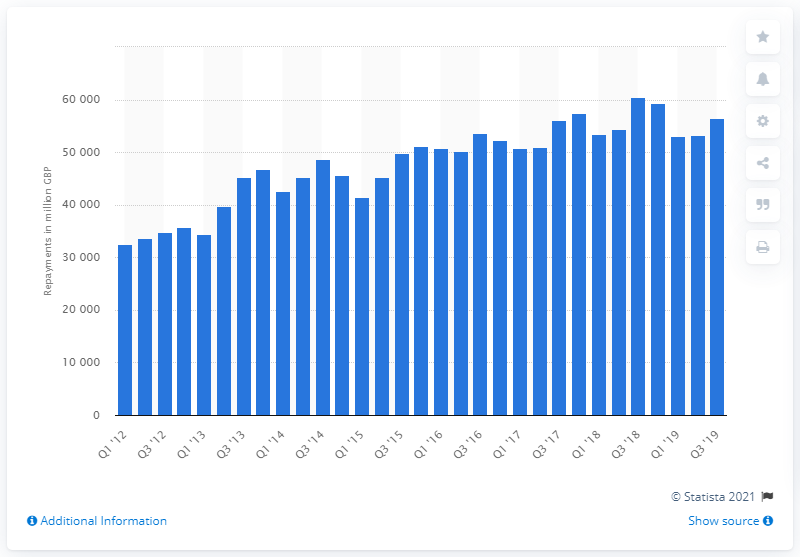Point out several critical features in this image. As of the third quarter of 2019, the total value of secured loans on dwellings was approximately 56,540. 